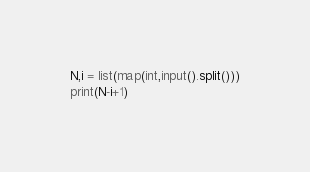<code> <loc_0><loc_0><loc_500><loc_500><_Python_>N,i = list(map(int,input().split()))
print(N-i+1)</code> 